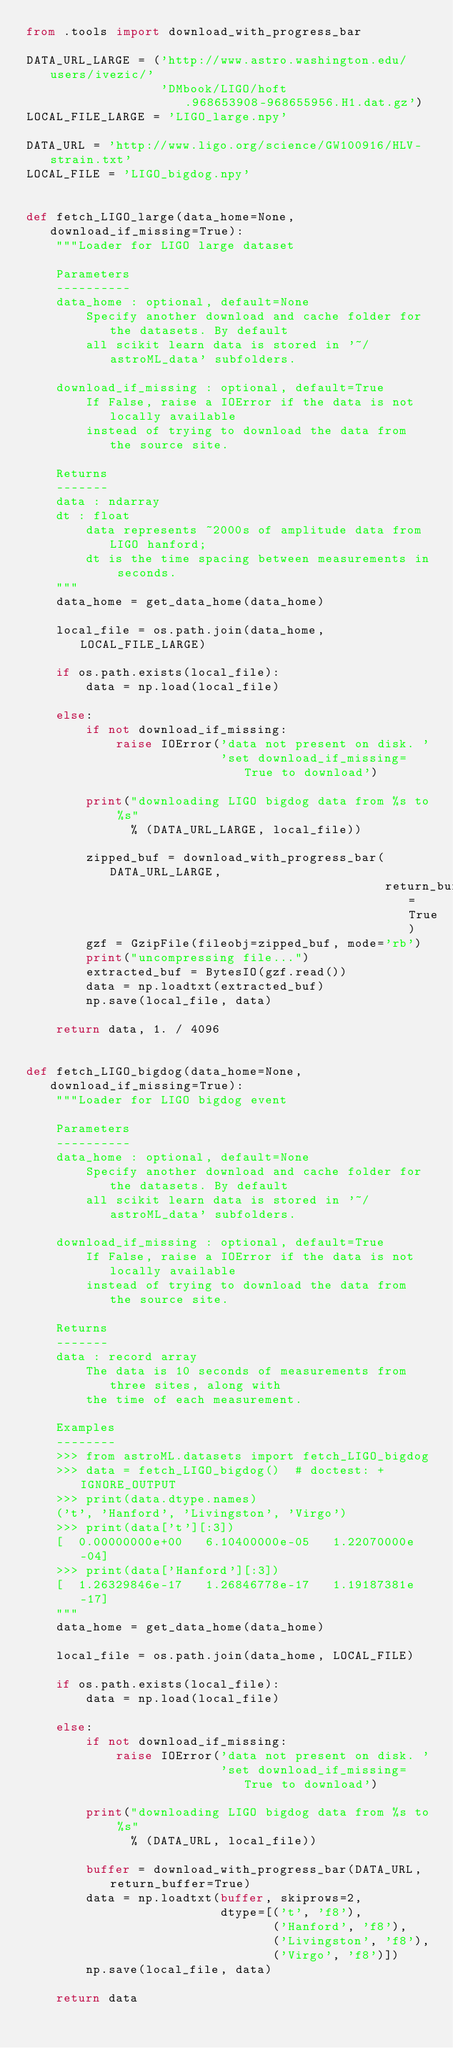Convert code to text. <code><loc_0><loc_0><loc_500><loc_500><_Python_>from .tools import download_with_progress_bar

DATA_URL_LARGE = ('http://www.astro.washington.edu/users/ivezic/'
                  'DMbook/LIGO/hoft.968653908-968655956.H1.dat.gz')
LOCAL_FILE_LARGE = 'LIGO_large.npy'

DATA_URL = 'http://www.ligo.org/science/GW100916/HLV-strain.txt'
LOCAL_FILE = 'LIGO_bigdog.npy'


def fetch_LIGO_large(data_home=None, download_if_missing=True):
    """Loader for LIGO large dataset

    Parameters
    ----------
    data_home : optional, default=None
        Specify another download and cache folder for the datasets. By default
        all scikit learn data is stored in '~/astroML_data' subfolders.

    download_if_missing : optional, default=True
        If False, raise a IOError if the data is not locally available
        instead of trying to download the data from the source site.

    Returns
    -------
    data : ndarray
    dt : float
        data represents ~2000s of amplitude data from LIGO hanford;
        dt is the time spacing between measurements in seconds.
    """
    data_home = get_data_home(data_home)

    local_file = os.path.join(data_home, LOCAL_FILE_LARGE)

    if os.path.exists(local_file):
        data = np.load(local_file)

    else:
        if not download_if_missing:
            raise IOError('data not present on disk. '
                          'set download_if_missing=True to download')

        print("downloading LIGO bigdog data from %s to %s"
              % (DATA_URL_LARGE, local_file))

        zipped_buf = download_with_progress_bar(DATA_URL_LARGE,
                                                return_buffer=True)
        gzf = GzipFile(fileobj=zipped_buf, mode='rb')
        print("uncompressing file...")
        extracted_buf = BytesIO(gzf.read())
        data = np.loadtxt(extracted_buf)
        np.save(local_file, data)

    return data, 1. / 4096


def fetch_LIGO_bigdog(data_home=None, download_if_missing=True):
    """Loader for LIGO bigdog event

    Parameters
    ----------
    data_home : optional, default=None
        Specify another download and cache folder for the datasets. By default
        all scikit learn data is stored in '~/astroML_data' subfolders.

    download_if_missing : optional, default=True
        If False, raise a IOError if the data is not locally available
        instead of trying to download the data from the source site.

    Returns
    -------
    data : record array
        The data is 10 seconds of measurements from three sites, along with
        the time of each measurement.

    Examples
    --------
    >>> from astroML.datasets import fetch_LIGO_bigdog
    >>> data = fetch_LIGO_bigdog()  # doctest: +IGNORE_OUTPUT
    >>> print(data.dtype.names)
    ('t', 'Hanford', 'Livingston', 'Virgo')
    >>> print(data['t'][:3])
    [  0.00000000e+00   6.10400000e-05   1.22070000e-04]
    >>> print(data['Hanford'][:3])
    [  1.26329846e-17   1.26846778e-17   1.19187381e-17]
    """
    data_home = get_data_home(data_home)

    local_file = os.path.join(data_home, LOCAL_FILE)

    if os.path.exists(local_file):
        data = np.load(local_file)

    else:
        if not download_if_missing:
            raise IOError('data not present on disk. '
                          'set download_if_missing=True to download')

        print("downloading LIGO bigdog data from %s to %s"
              % (DATA_URL, local_file))

        buffer = download_with_progress_bar(DATA_URL, return_buffer=True)
        data = np.loadtxt(buffer, skiprows=2,
                          dtype=[('t', 'f8'),
                                 ('Hanford', 'f8'),
                                 ('Livingston', 'f8'),
                                 ('Virgo', 'f8')])
        np.save(local_file, data)

    return data
</code> 